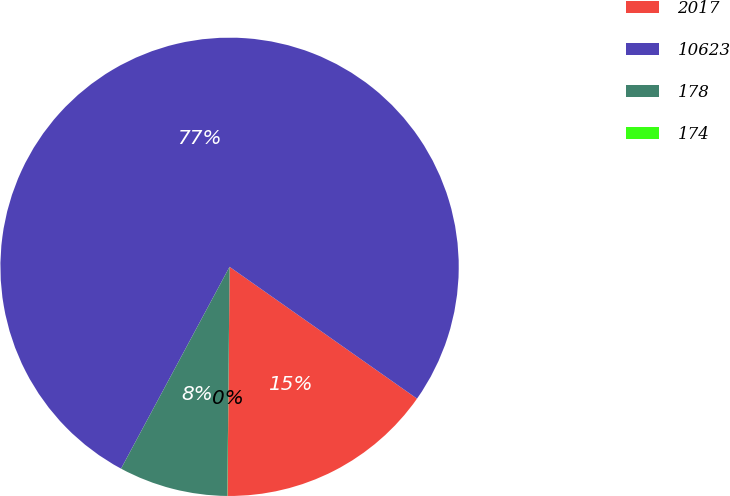Convert chart to OTSL. <chart><loc_0><loc_0><loc_500><loc_500><pie_chart><fcel>2017<fcel>10623<fcel>178<fcel>174<nl><fcel>15.39%<fcel>76.91%<fcel>7.7%<fcel>0.01%<nl></chart> 